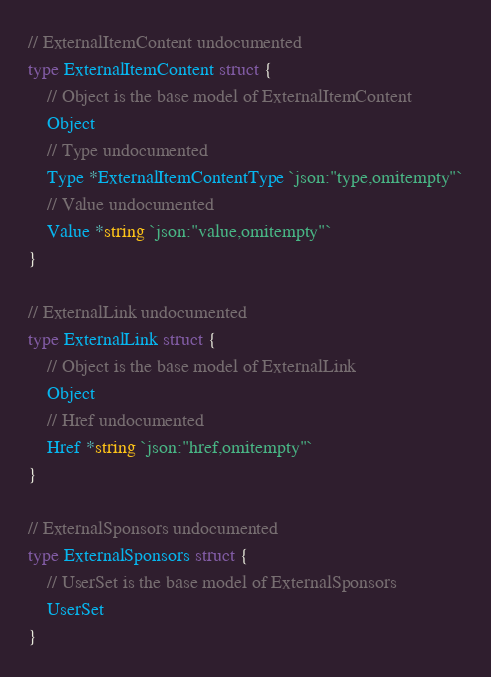Convert code to text. <code><loc_0><loc_0><loc_500><loc_500><_Go_>// ExternalItemContent undocumented
type ExternalItemContent struct {
	// Object is the base model of ExternalItemContent
	Object
	// Type undocumented
	Type *ExternalItemContentType `json:"type,omitempty"`
	// Value undocumented
	Value *string `json:"value,omitempty"`
}

// ExternalLink undocumented
type ExternalLink struct {
	// Object is the base model of ExternalLink
	Object
	// Href undocumented
	Href *string `json:"href,omitempty"`
}

// ExternalSponsors undocumented
type ExternalSponsors struct {
	// UserSet is the base model of ExternalSponsors
	UserSet
}
</code> 